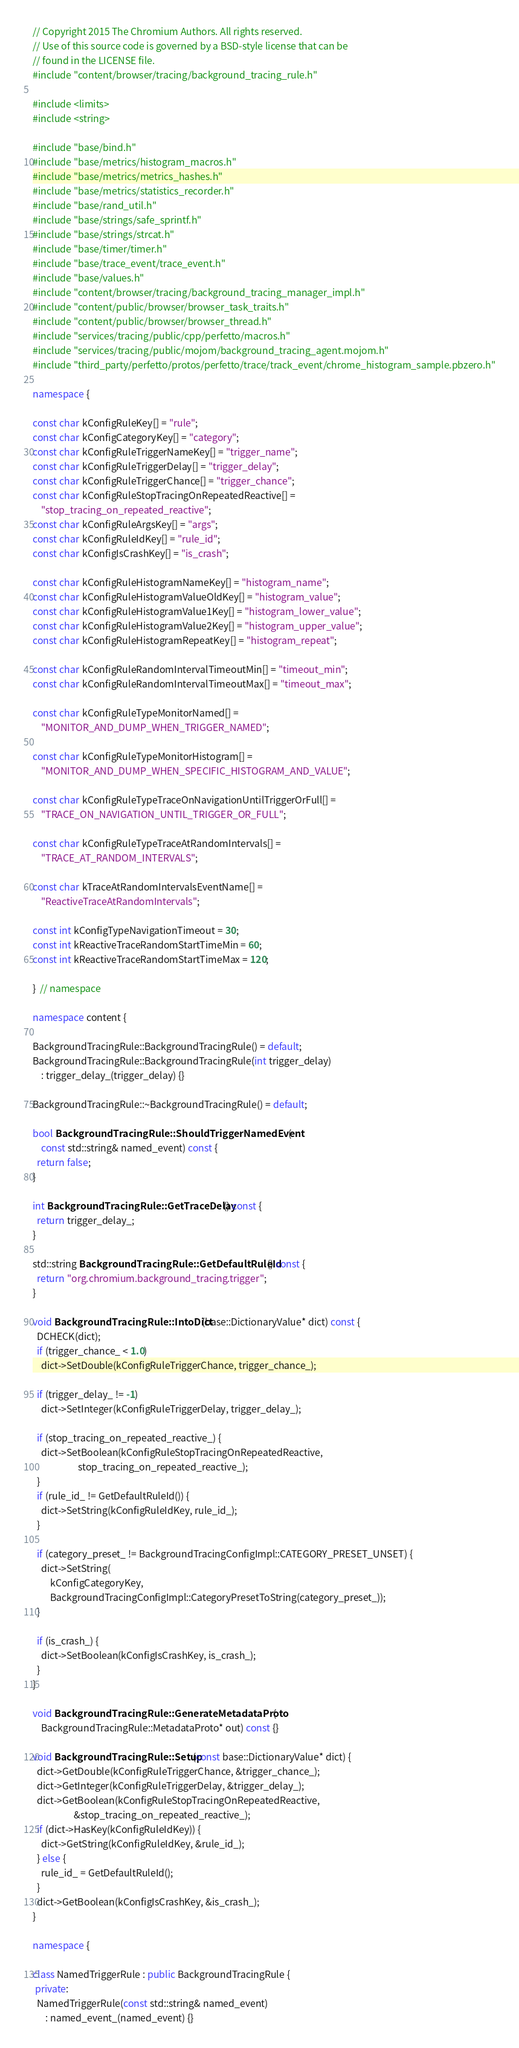<code> <loc_0><loc_0><loc_500><loc_500><_C++_>// Copyright 2015 The Chromium Authors. All rights reserved.
// Use of this source code is governed by a BSD-style license that can be
// found in the LICENSE file.
#include "content/browser/tracing/background_tracing_rule.h"

#include <limits>
#include <string>

#include "base/bind.h"
#include "base/metrics/histogram_macros.h"
#include "base/metrics/metrics_hashes.h"
#include "base/metrics/statistics_recorder.h"
#include "base/rand_util.h"
#include "base/strings/safe_sprintf.h"
#include "base/strings/strcat.h"
#include "base/timer/timer.h"
#include "base/trace_event/trace_event.h"
#include "base/values.h"
#include "content/browser/tracing/background_tracing_manager_impl.h"
#include "content/public/browser/browser_task_traits.h"
#include "content/public/browser/browser_thread.h"
#include "services/tracing/public/cpp/perfetto/macros.h"
#include "services/tracing/public/mojom/background_tracing_agent.mojom.h"
#include "third_party/perfetto/protos/perfetto/trace/track_event/chrome_histogram_sample.pbzero.h"

namespace {

const char kConfigRuleKey[] = "rule";
const char kConfigCategoryKey[] = "category";
const char kConfigRuleTriggerNameKey[] = "trigger_name";
const char kConfigRuleTriggerDelay[] = "trigger_delay";
const char kConfigRuleTriggerChance[] = "trigger_chance";
const char kConfigRuleStopTracingOnRepeatedReactive[] =
    "stop_tracing_on_repeated_reactive";
const char kConfigRuleArgsKey[] = "args";
const char kConfigRuleIdKey[] = "rule_id";
const char kConfigIsCrashKey[] = "is_crash";

const char kConfigRuleHistogramNameKey[] = "histogram_name";
const char kConfigRuleHistogramValueOldKey[] = "histogram_value";
const char kConfigRuleHistogramValue1Key[] = "histogram_lower_value";
const char kConfigRuleHistogramValue2Key[] = "histogram_upper_value";
const char kConfigRuleHistogramRepeatKey[] = "histogram_repeat";

const char kConfigRuleRandomIntervalTimeoutMin[] = "timeout_min";
const char kConfigRuleRandomIntervalTimeoutMax[] = "timeout_max";

const char kConfigRuleTypeMonitorNamed[] =
    "MONITOR_AND_DUMP_WHEN_TRIGGER_NAMED";

const char kConfigRuleTypeMonitorHistogram[] =
    "MONITOR_AND_DUMP_WHEN_SPECIFIC_HISTOGRAM_AND_VALUE";

const char kConfigRuleTypeTraceOnNavigationUntilTriggerOrFull[] =
    "TRACE_ON_NAVIGATION_UNTIL_TRIGGER_OR_FULL";

const char kConfigRuleTypeTraceAtRandomIntervals[] =
    "TRACE_AT_RANDOM_INTERVALS";

const char kTraceAtRandomIntervalsEventName[] =
    "ReactiveTraceAtRandomIntervals";

const int kConfigTypeNavigationTimeout = 30;
const int kReactiveTraceRandomStartTimeMin = 60;
const int kReactiveTraceRandomStartTimeMax = 120;

}  // namespace

namespace content {

BackgroundTracingRule::BackgroundTracingRule() = default;
BackgroundTracingRule::BackgroundTracingRule(int trigger_delay)
    : trigger_delay_(trigger_delay) {}

BackgroundTracingRule::~BackgroundTracingRule() = default;

bool BackgroundTracingRule::ShouldTriggerNamedEvent(
    const std::string& named_event) const {
  return false;
}

int BackgroundTracingRule::GetTraceDelay() const {
  return trigger_delay_;
}

std::string BackgroundTracingRule::GetDefaultRuleId() const {
  return "org.chromium.background_tracing.trigger";
}

void BackgroundTracingRule::IntoDict(base::DictionaryValue* dict) const {
  DCHECK(dict);
  if (trigger_chance_ < 1.0)
    dict->SetDouble(kConfigRuleTriggerChance, trigger_chance_);

  if (trigger_delay_ != -1)
    dict->SetInteger(kConfigRuleTriggerDelay, trigger_delay_);

  if (stop_tracing_on_repeated_reactive_) {
    dict->SetBoolean(kConfigRuleStopTracingOnRepeatedReactive,
                     stop_tracing_on_repeated_reactive_);
  }
  if (rule_id_ != GetDefaultRuleId()) {
    dict->SetString(kConfigRuleIdKey, rule_id_);
  }

  if (category_preset_ != BackgroundTracingConfigImpl::CATEGORY_PRESET_UNSET) {
    dict->SetString(
        kConfigCategoryKey,
        BackgroundTracingConfigImpl::CategoryPresetToString(category_preset_));
  }

  if (is_crash_) {
    dict->SetBoolean(kConfigIsCrashKey, is_crash_);
  }
}

void BackgroundTracingRule::GenerateMetadataProto(
    BackgroundTracingRule::MetadataProto* out) const {}

void BackgroundTracingRule::Setup(const base::DictionaryValue* dict) {
  dict->GetDouble(kConfigRuleTriggerChance, &trigger_chance_);
  dict->GetInteger(kConfigRuleTriggerDelay, &trigger_delay_);
  dict->GetBoolean(kConfigRuleStopTracingOnRepeatedReactive,
                   &stop_tracing_on_repeated_reactive_);
  if (dict->HasKey(kConfigRuleIdKey)) {
    dict->GetString(kConfigRuleIdKey, &rule_id_);
  } else {
    rule_id_ = GetDefaultRuleId();
  }
  dict->GetBoolean(kConfigIsCrashKey, &is_crash_);
}

namespace {

class NamedTriggerRule : public BackgroundTracingRule {
 private:
  NamedTriggerRule(const std::string& named_event)
      : named_event_(named_event) {}
</code> 